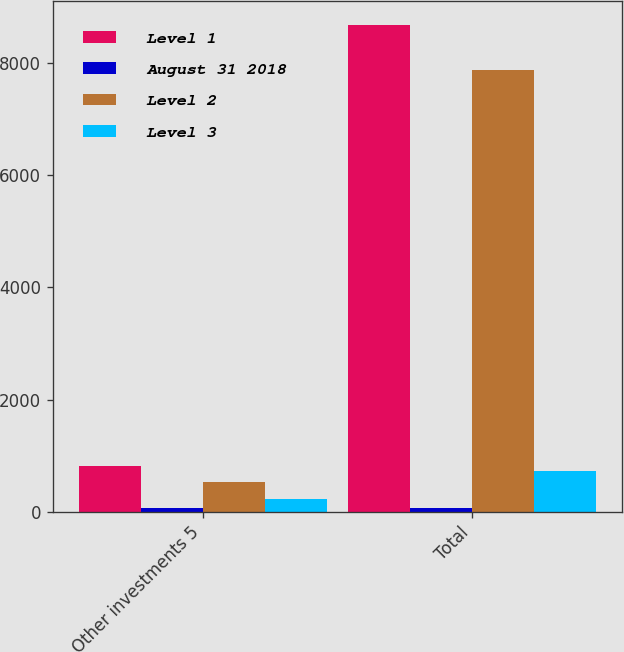Convert chart to OTSL. <chart><loc_0><loc_0><loc_500><loc_500><stacked_bar_chart><ecel><fcel>Other investments 5<fcel>Total<nl><fcel>Level 1<fcel>822<fcel>8676<nl><fcel>August 31 2018<fcel>64<fcel>64<nl><fcel>Level 2<fcel>531<fcel>7878<nl><fcel>Level 3<fcel>227<fcel>734<nl></chart> 